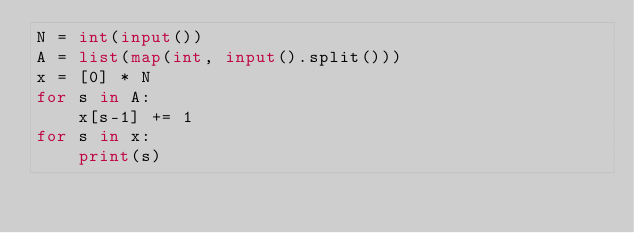Convert code to text. <code><loc_0><loc_0><loc_500><loc_500><_Python_>N = int(input())
A = list(map(int, input().split()))
x = [0] * N
for s in A:
    x[s-1] += 1
for s in x:
    print(s)</code> 